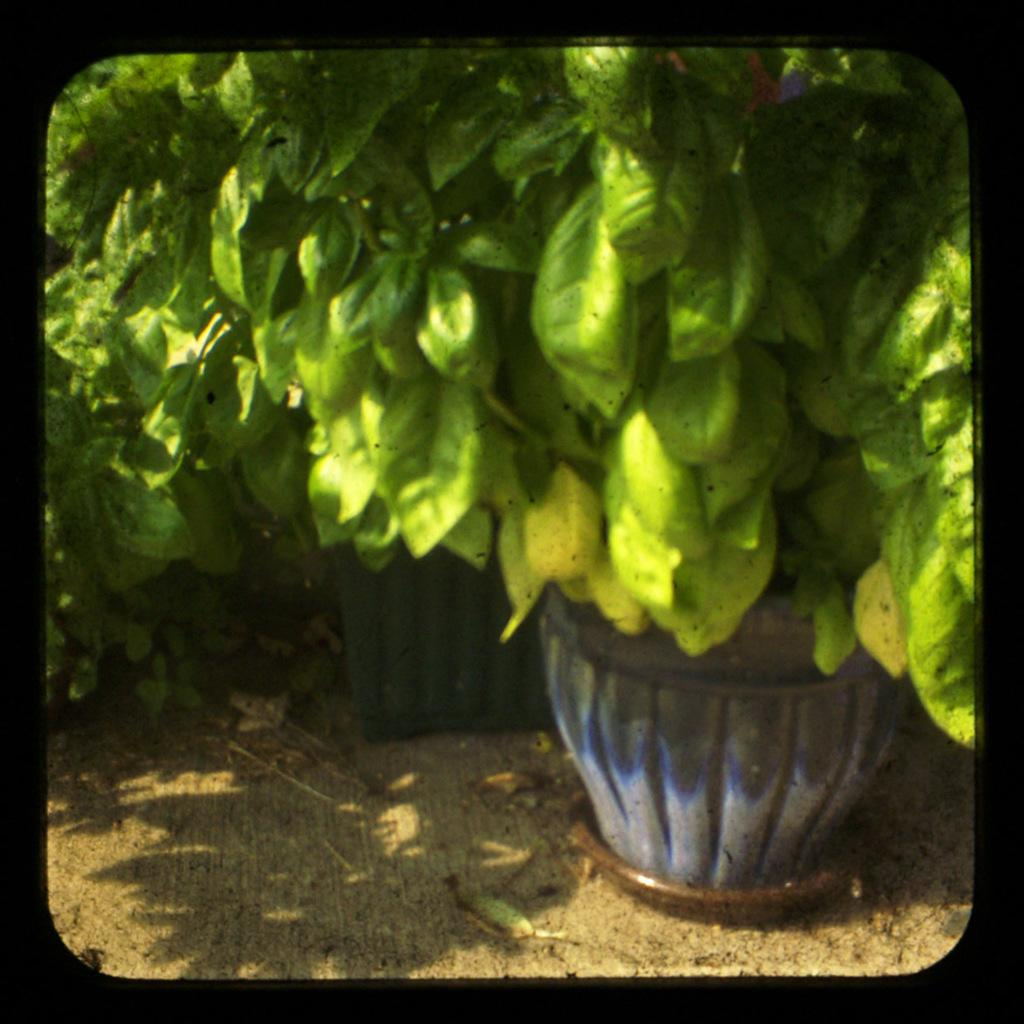What type of objects can be seen in the image? There are plant pots in the image. Where are the plant pots located? The plant pots are on the land. What type of operation is being performed in the image? There is no operation being performed in the image; it only features plant pots on the land. What type of playground equipment can be seen in the image? There is no playground equipment present in the image; it only features plant pots on the land. 